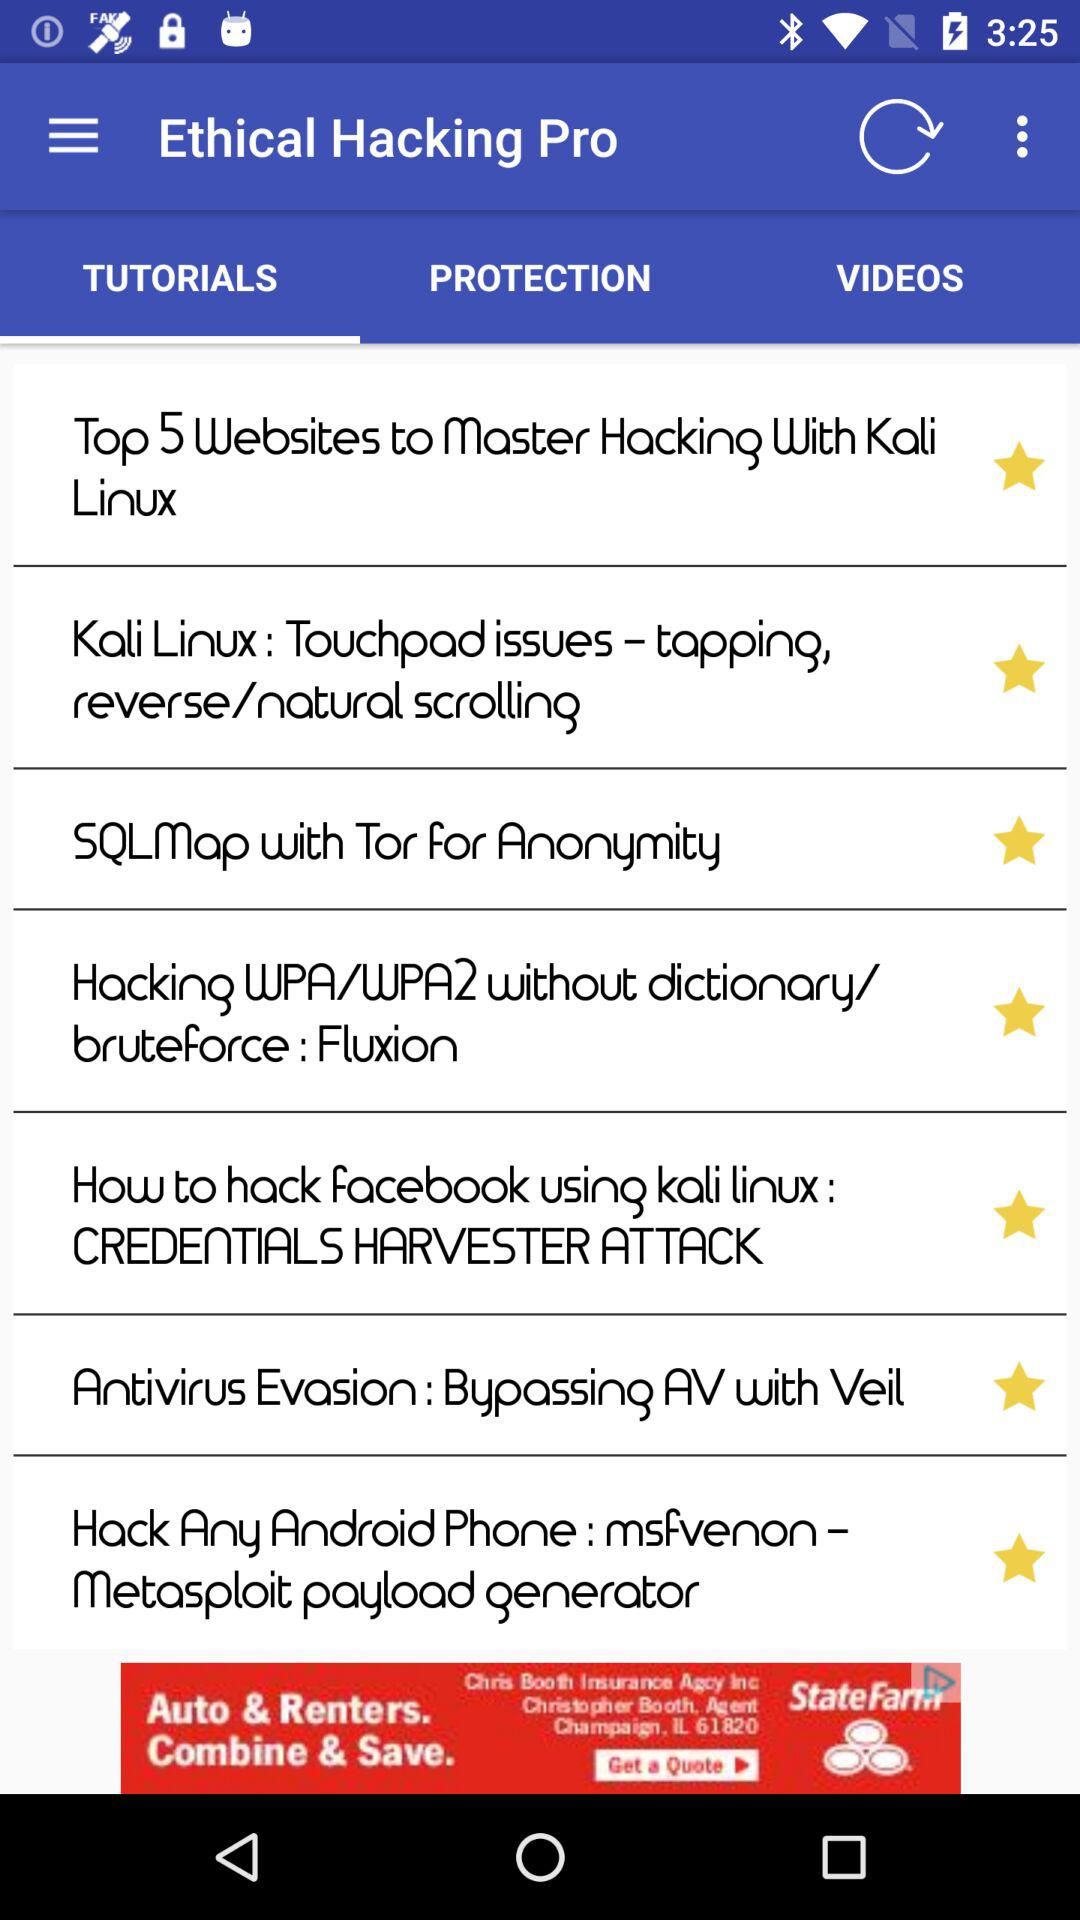Which language has been chosen? The chosen language is English. 